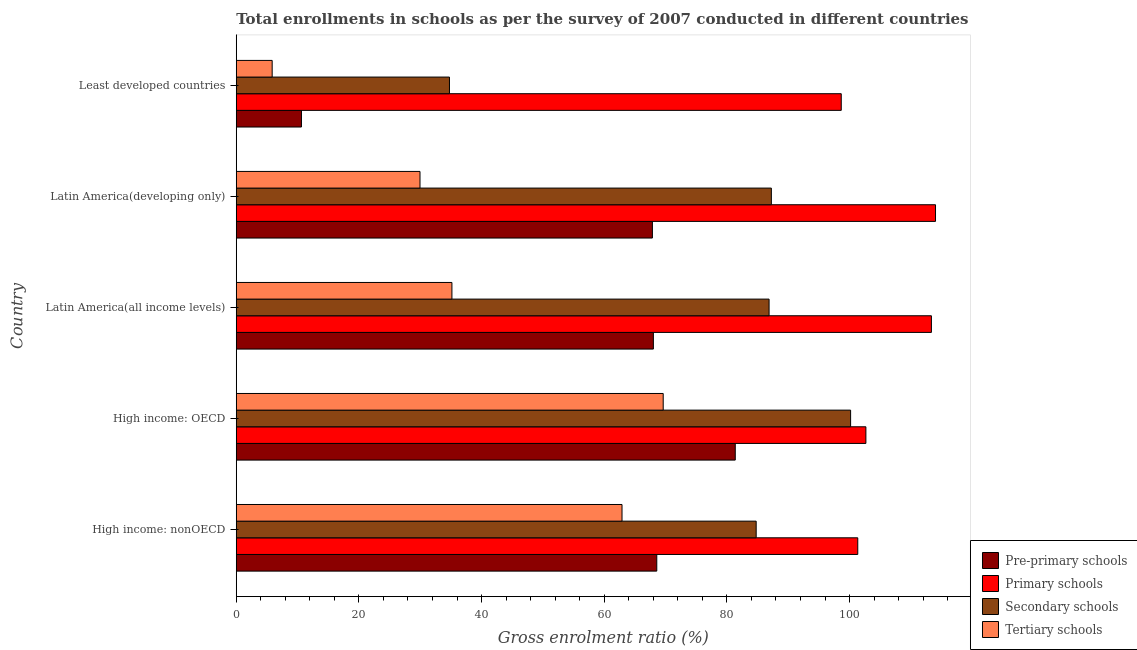Are the number of bars per tick equal to the number of legend labels?
Ensure brevity in your answer.  Yes. How many bars are there on the 4th tick from the top?
Your answer should be compact. 4. What is the label of the 2nd group of bars from the top?
Give a very brief answer. Latin America(developing only). What is the gross enrolment ratio in pre-primary schools in Least developed countries?
Provide a short and direct response. 10.63. Across all countries, what is the maximum gross enrolment ratio in tertiary schools?
Make the answer very short. 69.61. Across all countries, what is the minimum gross enrolment ratio in secondary schools?
Provide a short and direct response. 34.76. In which country was the gross enrolment ratio in pre-primary schools maximum?
Keep it short and to the point. High income: OECD. In which country was the gross enrolment ratio in pre-primary schools minimum?
Your response must be concise. Least developed countries. What is the total gross enrolment ratio in pre-primary schools in the graph?
Give a very brief answer. 296.41. What is the difference between the gross enrolment ratio in tertiary schools in High income: OECD and that in Latin America(developing only)?
Offer a terse response. 39.65. What is the difference between the gross enrolment ratio in secondary schools in High income: OECD and the gross enrolment ratio in pre-primary schools in High income: nonOECD?
Provide a short and direct response. 31.6. What is the average gross enrolment ratio in tertiary schools per country?
Ensure brevity in your answer.  40.7. What is the difference between the gross enrolment ratio in primary schools and gross enrolment ratio in pre-primary schools in Latin America(all income levels)?
Ensure brevity in your answer.  45.33. In how many countries, is the gross enrolment ratio in pre-primary schools greater than 44 %?
Provide a succinct answer. 4. What is the ratio of the gross enrolment ratio in pre-primary schools in Latin America(developing only) to that in Least developed countries?
Your answer should be compact. 6.38. Is the gross enrolment ratio in tertiary schools in High income: OECD less than that in High income: nonOECD?
Offer a very short reply. No. Is the difference between the gross enrolment ratio in secondary schools in High income: nonOECD and Latin America(all income levels) greater than the difference between the gross enrolment ratio in pre-primary schools in High income: nonOECD and Latin America(all income levels)?
Provide a succinct answer. No. What is the difference between the highest and the second highest gross enrolment ratio in tertiary schools?
Offer a very short reply. 6.72. What is the difference between the highest and the lowest gross enrolment ratio in primary schools?
Give a very brief answer. 15.37. In how many countries, is the gross enrolment ratio in primary schools greater than the average gross enrolment ratio in primary schools taken over all countries?
Provide a succinct answer. 2. Is the sum of the gross enrolment ratio in secondary schools in Latin America(developing only) and Least developed countries greater than the maximum gross enrolment ratio in tertiary schools across all countries?
Give a very brief answer. Yes. Is it the case that in every country, the sum of the gross enrolment ratio in tertiary schools and gross enrolment ratio in secondary schools is greater than the sum of gross enrolment ratio in primary schools and gross enrolment ratio in pre-primary schools?
Your answer should be very brief. No. What does the 2nd bar from the top in Least developed countries represents?
Give a very brief answer. Secondary schools. What does the 4th bar from the bottom in Latin America(developing only) represents?
Keep it short and to the point. Tertiary schools. Is it the case that in every country, the sum of the gross enrolment ratio in pre-primary schools and gross enrolment ratio in primary schools is greater than the gross enrolment ratio in secondary schools?
Your response must be concise. Yes. How many countries are there in the graph?
Make the answer very short. 5. Where does the legend appear in the graph?
Make the answer very short. Bottom right. What is the title of the graph?
Your answer should be compact. Total enrollments in schools as per the survey of 2007 conducted in different countries. Does "Taxes on revenue" appear as one of the legend labels in the graph?
Your answer should be compact. No. What is the label or title of the Y-axis?
Your answer should be compact. Country. What is the Gross enrolment ratio (%) in Pre-primary schools in High income: nonOECD?
Provide a succinct answer. 68.56. What is the Gross enrolment ratio (%) in Primary schools in High income: nonOECD?
Ensure brevity in your answer.  101.33. What is the Gross enrolment ratio (%) of Secondary schools in High income: nonOECD?
Provide a succinct answer. 84.77. What is the Gross enrolment ratio (%) in Tertiary schools in High income: nonOECD?
Keep it short and to the point. 62.9. What is the Gross enrolment ratio (%) in Pre-primary schools in High income: OECD?
Provide a succinct answer. 81.36. What is the Gross enrolment ratio (%) in Primary schools in High income: OECD?
Ensure brevity in your answer.  102.66. What is the Gross enrolment ratio (%) in Secondary schools in High income: OECD?
Offer a very short reply. 100.17. What is the Gross enrolment ratio (%) in Tertiary schools in High income: OECD?
Provide a succinct answer. 69.61. What is the Gross enrolment ratio (%) in Pre-primary schools in Latin America(all income levels)?
Keep it short and to the point. 68.01. What is the Gross enrolment ratio (%) in Primary schools in Latin America(all income levels)?
Make the answer very short. 113.34. What is the Gross enrolment ratio (%) of Secondary schools in Latin America(all income levels)?
Your answer should be compact. 86.87. What is the Gross enrolment ratio (%) of Tertiary schools in Latin America(all income levels)?
Make the answer very short. 35.16. What is the Gross enrolment ratio (%) of Pre-primary schools in Latin America(developing only)?
Make the answer very short. 67.85. What is the Gross enrolment ratio (%) in Primary schools in Latin America(developing only)?
Your response must be concise. 114.01. What is the Gross enrolment ratio (%) in Secondary schools in Latin America(developing only)?
Give a very brief answer. 87.24. What is the Gross enrolment ratio (%) of Tertiary schools in Latin America(developing only)?
Ensure brevity in your answer.  29.96. What is the Gross enrolment ratio (%) of Pre-primary schools in Least developed countries?
Your response must be concise. 10.63. What is the Gross enrolment ratio (%) in Primary schools in Least developed countries?
Give a very brief answer. 98.64. What is the Gross enrolment ratio (%) in Secondary schools in Least developed countries?
Provide a succinct answer. 34.76. What is the Gross enrolment ratio (%) of Tertiary schools in Least developed countries?
Offer a terse response. 5.86. Across all countries, what is the maximum Gross enrolment ratio (%) of Pre-primary schools?
Keep it short and to the point. 81.36. Across all countries, what is the maximum Gross enrolment ratio (%) in Primary schools?
Provide a succinct answer. 114.01. Across all countries, what is the maximum Gross enrolment ratio (%) in Secondary schools?
Provide a short and direct response. 100.17. Across all countries, what is the maximum Gross enrolment ratio (%) in Tertiary schools?
Your response must be concise. 69.61. Across all countries, what is the minimum Gross enrolment ratio (%) in Pre-primary schools?
Your answer should be compact. 10.63. Across all countries, what is the minimum Gross enrolment ratio (%) of Primary schools?
Make the answer very short. 98.64. Across all countries, what is the minimum Gross enrolment ratio (%) in Secondary schools?
Provide a succinct answer. 34.76. Across all countries, what is the minimum Gross enrolment ratio (%) of Tertiary schools?
Keep it short and to the point. 5.86. What is the total Gross enrolment ratio (%) of Pre-primary schools in the graph?
Your response must be concise. 296.41. What is the total Gross enrolment ratio (%) of Primary schools in the graph?
Your answer should be compact. 529.98. What is the total Gross enrolment ratio (%) in Secondary schools in the graph?
Ensure brevity in your answer.  393.82. What is the total Gross enrolment ratio (%) of Tertiary schools in the graph?
Make the answer very short. 203.49. What is the difference between the Gross enrolment ratio (%) in Pre-primary schools in High income: nonOECD and that in High income: OECD?
Your answer should be very brief. -12.8. What is the difference between the Gross enrolment ratio (%) in Primary schools in High income: nonOECD and that in High income: OECD?
Your answer should be compact. -1.33. What is the difference between the Gross enrolment ratio (%) of Secondary schools in High income: nonOECD and that in High income: OECD?
Make the answer very short. -15.4. What is the difference between the Gross enrolment ratio (%) in Tertiary schools in High income: nonOECD and that in High income: OECD?
Give a very brief answer. -6.72. What is the difference between the Gross enrolment ratio (%) of Pre-primary schools in High income: nonOECD and that in Latin America(all income levels)?
Offer a terse response. 0.56. What is the difference between the Gross enrolment ratio (%) of Primary schools in High income: nonOECD and that in Latin America(all income levels)?
Offer a very short reply. -12.01. What is the difference between the Gross enrolment ratio (%) in Secondary schools in High income: nonOECD and that in Latin America(all income levels)?
Offer a very short reply. -2.1. What is the difference between the Gross enrolment ratio (%) in Tertiary schools in High income: nonOECD and that in Latin America(all income levels)?
Your answer should be very brief. 27.73. What is the difference between the Gross enrolment ratio (%) in Pre-primary schools in High income: nonOECD and that in Latin America(developing only)?
Offer a very short reply. 0.71. What is the difference between the Gross enrolment ratio (%) in Primary schools in High income: nonOECD and that in Latin America(developing only)?
Give a very brief answer. -12.68. What is the difference between the Gross enrolment ratio (%) in Secondary schools in High income: nonOECD and that in Latin America(developing only)?
Ensure brevity in your answer.  -2.47. What is the difference between the Gross enrolment ratio (%) in Tertiary schools in High income: nonOECD and that in Latin America(developing only)?
Provide a short and direct response. 32.94. What is the difference between the Gross enrolment ratio (%) in Pre-primary schools in High income: nonOECD and that in Least developed countries?
Offer a very short reply. 57.93. What is the difference between the Gross enrolment ratio (%) of Primary schools in High income: nonOECD and that in Least developed countries?
Your answer should be compact. 2.69. What is the difference between the Gross enrolment ratio (%) of Secondary schools in High income: nonOECD and that in Least developed countries?
Your response must be concise. 50.01. What is the difference between the Gross enrolment ratio (%) in Tertiary schools in High income: nonOECD and that in Least developed countries?
Your response must be concise. 57.04. What is the difference between the Gross enrolment ratio (%) in Pre-primary schools in High income: OECD and that in Latin America(all income levels)?
Your response must be concise. 13.35. What is the difference between the Gross enrolment ratio (%) in Primary schools in High income: OECD and that in Latin America(all income levels)?
Give a very brief answer. -10.68. What is the difference between the Gross enrolment ratio (%) of Secondary schools in High income: OECD and that in Latin America(all income levels)?
Your answer should be very brief. 13.29. What is the difference between the Gross enrolment ratio (%) of Tertiary schools in High income: OECD and that in Latin America(all income levels)?
Your answer should be compact. 34.45. What is the difference between the Gross enrolment ratio (%) in Pre-primary schools in High income: OECD and that in Latin America(developing only)?
Provide a short and direct response. 13.51. What is the difference between the Gross enrolment ratio (%) of Primary schools in High income: OECD and that in Latin America(developing only)?
Provide a short and direct response. -11.35. What is the difference between the Gross enrolment ratio (%) in Secondary schools in High income: OECD and that in Latin America(developing only)?
Offer a very short reply. 12.92. What is the difference between the Gross enrolment ratio (%) in Tertiary schools in High income: OECD and that in Latin America(developing only)?
Offer a very short reply. 39.65. What is the difference between the Gross enrolment ratio (%) in Pre-primary schools in High income: OECD and that in Least developed countries?
Provide a short and direct response. 70.73. What is the difference between the Gross enrolment ratio (%) in Primary schools in High income: OECD and that in Least developed countries?
Your answer should be very brief. 4.02. What is the difference between the Gross enrolment ratio (%) of Secondary schools in High income: OECD and that in Least developed countries?
Provide a short and direct response. 65.4. What is the difference between the Gross enrolment ratio (%) in Tertiary schools in High income: OECD and that in Least developed countries?
Your answer should be compact. 63.76. What is the difference between the Gross enrolment ratio (%) in Pre-primary schools in Latin America(all income levels) and that in Latin America(developing only)?
Offer a terse response. 0.16. What is the difference between the Gross enrolment ratio (%) of Primary schools in Latin America(all income levels) and that in Latin America(developing only)?
Provide a succinct answer. -0.67. What is the difference between the Gross enrolment ratio (%) in Secondary schools in Latin America(all income levels) and that in Latin America(developing only)?
Provide a succinct answer. -0.37. What is the difference between the Gross enrolment ratio (%) in Tertiary schools in Latin America(all income levels) and that in Latin America(developing only)?
Your answer should be very brief. 5.2. What is the difference between the Gross enrolment ratio (%) of Pre-primary schools in Latin America(all income levels) and that in Least developed countries?
Ensure brevity in your answer.  57.38. What is the difference between the Gross enrolment ratio (%) of Primary schools in Latin America(all income levels) and that in Least developed countries?
Your response must be concise. 14.7. What is the difference between the Gross enrolment ratio (%) of Secondary schools in Latin America(all income levels) and that in Least developed countries?
Make the answer very short. 52.11. What is the difference between the Gross enrolment ratio (%) in Tertiary schools in Latin America(all income levels) and that in Least developed countries?
Your answer should be very brief. 29.31. What is the difference between the Gross enrolment ratio (%) of Pre-primary schools in Latin America(developing only) and that in Least developed countries?
Give a very brief answer. 57.22. What is the difference between the Gross enrolment ratio (%) in Primary schools in Latin America(developing only) and that in Least developed countries?
Your response must be concise. 15.37. What is the difference between the Gross enrolment ratio (%) in Secondary schools in Latin America(developing only) and that in Least developed countries?
Give a very brief answer. 52.48. What is the difference between the Gross enrolment ratio (%) of Tertiary schools in Latin America(developing only) and that in Least developed countries?
Provide a short and direct response. 24.1. What is the difference between the Gross enrolment ratio (%) of Pre-primary schools in High income: nonOECD and the Gross enrolment ratio (%) of Primary schools in High income: OECD?
Your answer should be compact. -34.09. What is the difference between the Gross enrolment ratio (%) of Pre-primary schools in High income: nonOECD and the Gross enrolment ratio (%) of Secondary schools in High income: OECD?
Give a very brief answer. -31.6. What is the difference between the Gross enrolment ratio (%) in Pre-primary schools in High income: nonOECD and the Gross enrolment ratio (%) in Tertiary schools in High income: OECD?
Keep it short and to the point. -1.05. What is the difference between the Gross enrolment ratio (%) in Primary schools in High income: nonOECD and the Gross enrolment ratio (%) in Secondary schools in High income: OECD?
Keep it short and to the point. 1.17. What is the difference between the Gross enrolment ratio (%) in Primary schools in High income: nonOECD and the Gross enrolment ratio (%) in Tertiary schools in High income: OECD?
Make the answer very short. 31.72. What is the difference between the Gross enrolment ratio (%) of Secondary schools in High income: nonOECD and the Gross enrolment ratio (%) of Tertiary schools in High income: OECD?
Offer a very short reply. 15.16. What is the difference between the Gross enrolment ratio (%) in Pre-primary schools in High income: nonOECD and the Gross enrolment ratio (%) in Primary schools in Latin America(all income levels)?
Offer a very short reply. -44.78. What is the difference between the Gross enrolment ratio (%) in Pre-primary schools in High income: nonOECD and the Gross enrolment ratio (%) in Secondary schools in Latin America(all income levels)?
Provide a succinct answer. -18.31. What is the difference between the Gross enrolment ratio (%) of Pre-primary schools in High income: nonOECD and the Gross enrolment ratio (%) of Tertiary schools in Latin America(all income levels)?
Your response must be concise. 33.4. What is the difference between the Gross enrolment ratio (%) in Primary schools in High income: nonOECD and the Gross enrolment ratio (%) in Secondary schools in Latin America(all income levels)?
Make the answer very short. 14.46. What is the difference between the Gross enrolment ratio (%) of Primary schools in High income: nonOECD and the Gross enrolment ratio (%) of Tertiary schools in Latin America(all income levels)?
Keep it short and to the point. 66.17. What is the difference between the Gross enrolment ratio (%) in Secondary schools in High income: nonOECD and the Gross enrolment ratio (%) in Tertiary schools in Latin America(all income levels)?
Ensure brevity in your answer.  49.61. What is the difference between the Gross enrolment ratio (%) of Pre-primary schools in High income: nonOECD and the Gross enrolment ratio (%) of Primary schools in Latin America(developing only)?
Your answer should be very brief. -45.45. What is the difference between the Gross enrolment ratio (%) in Pre-primary schools in High income: nonOECD and the Gross enrolment ratio (%) in Secondary schools in Latin America(developing only)?
Give a very brief answer. -18.68. What is the difference between the Gross enrolment ratio (%) of Pre-primary schools in High income: nonOECD and the Gross enrolment ratio (%) of Tertiary schools in Latin America(developing only)?
Your answer should be compact. 38.6. What is the difference between the Gross enrolment ratio (%) in Primary schools in High income: nonOECD and the Gross enrolment ratio (%) in Secondary schools in Latin America(developing only)?
Keep it short and to the point. 14.09. What is the difference between the Gross enrolment ratio (%) in Primary schools in High income: nonOECD and the Gross enrolment ratio (%) in Tertiary schools in Latin America(developing only)?
Give a very brief answer. 71.37. What is the difference between the Gross enrolment ratio (%) in Secondary schools in High income: nonOECD and the Gross enrolment ratio (%) in Tertiary schools in Latin America(developing only)?
Your answer should be compact. 54.81. What is the difference between the Gross enrolment ratio (%) in Pre-primary schools in High income: nonOECD and the Gross enrolment ratio (%) in Primary schools in Least developed countries?
Give a very brief answer. -30.08. What is the difference between the Gross enrolment ratio (%) in Pre-primary schools in High income: nonOECD and the Gross enrolment ratio (%) in Secondary schools in Least developed countries?
Provide a short and direct response. 33.8. What is the difference between the Gross enrolment ratio (%) in Pre-primary schools in High income: nonOECD and the Gross enrolment ratio (%) in Tertiary schools in Least developed countries?
Ensure brevity in your answer.  62.71. What is the difference between the Gross enrolment ratio (%) in Primary schools in High income: nonOECD and the Gross enrolment ratio (%) in Secondary schools in Least developed countries?
Ensure brevity in your answer.  66.57. What is the difference between the Gross enrolment ratio (%) in Primary schools in High income: nonOECD and the Gross enrolment ratio (%) in Tertiary schools in Least developed countries?
Offer a very short reply. 95.48. What is the difference between the Gross enrolment ratio (%) in Secondary schools in High income: nonOECD and the Gross enrolment ratio (%) in Tertiary schools in Least developed countries?
Make the answer very short. 78.91. What is the difference between the Gross enrolment ratio (%) of Pre-primary schools in High income: OECD and the Gross enrolment ratio (%) of Primary schools in Latin America(all income levels)?
Keep it short and to the point. -31.98. What is the difference between the Gross enrolment ratio (%) in Pre-primary schools in High income: OECD and the Gross enrolment ratio (%) in Secondary schools in Latin America(all income levels)?
Offer a terse response. -5.51. What is the difference between the Gross enrolment ratio (%) in Pre-primary schools in High income: OECD and the Gross enrolment ratio (%) in Tertiary schools in Latin America(all income levels)?
Offer a very short reply. 46.2. What is the difference between the Gross enrolment ratio (%) in Primary schools in High income: OECD and the Gross enrolment ratio (%) in Secondary schools in Latin America(all income levels)?
Ensure brevity in your answer.  15.78. What is the difference between the Gross enrolment ratio (%) in Primary schools in High income: OECD and the Gross enrolment ratio (%) in Tertiary schools in Latin America(all income levels)?
Your response must be concise. 67.5. What is the difference between the Gross enrolment ratio (%) of Secondary schools in High income: OECD and the Gross enrolment ratio (%) of Tertiary schools in Latin America(all income levels)?
Ensure brevity in your answer.  65. What is the difference between the Gross enrolment ratio (%) of Pre-primary schools in High income: OECD and the Gross enrolment ratio (%) of Primary schools in Latin America(developing only)?
Make the answer very short. -32.65. What is the difference between the Gross enrolment ratio (%) of Pre-primary schools in High income: OECD and the Gross enrolment ratio (%) of Secondary schools in Latin America(developing only)?
Ensure brevity in your answer.  -5.88. What is the difference between the Gross enrolment ratio (%) of Pre-primary schools in High income: OECD and the Gross enrolment ratio (%) of Tertiary schools in Latin America(developing only)?
Your answer should be very brief. 51.4. What is the difference between the Gross enrolment ratio (%) in Primary schools in High income: OECD and the Gross enrolment ratio (%) in Secondary schools in Latin America(developing only)?
Provide a short and direct response. 15.41. What is the difference between the Gross enrolment ratio (%) of Primary schools in High income: OECD and the Gross enrolment ratio (%) of Tertiary schools in Latin America(developing only)?
Your answer should be compact. 72.7. What is the difference between the Gross enrolment ratio (%) of Secondary schools in High income: OECD and the Gross enrolment ratio (%) of Tertiary schools in Latin America(developing only)?
Give a very brief answer. 70.21. What is the difference between the Gross enrolment ratio (%) of Pre-primary schools in High income: OECD and the Gross enrolment ratio (%) of Primary schools in Least developed countries?
Offer a very short reply. -17.28. What is the difference between the Gross enrolment ratio (%) of Pre-primary schools in High income: OECD and the Gross enrolment ratio (%) of Secondary schools in Least developed countries?
Your answer should be very brief. 46.6. What is the difference between the Gross enrolment ratio (%) in Pre-primary schools in High income: OECD and the Gross enrolment ratio (%) in Tertiary schools in Least developed countries?
Offer a terse response. 75.5. What is the difference between the Gross enrolment ratio (%) of Primary schools in High income: OECD and the Gross enrolment ratio (%) of Secondary schools in Least developed countries?
Ensure brevity in your answer.  67.89. What is the difference between the Gross enrolment ratio (%) of Primary schools in High income: OECD and the Gross enrolment ratio (%) of Tertiary schools in Least developed countries?
Provide a succinct answer. 96.8. What is the difference between the Gross enrolment ratio (%) of Secondary schools in High income: OECD and the Gross enrolment ratio (%) of Tertiary schools in Least developed countries?
Ensure brevity in your answer.  94.31. What is the difference between the Gross enrolment ratio (%) of Pre-primary schools in Latin America(all income levels) and the Gross enrolment ratio (%) of Primary schools in Latin America(developing only)?
Provide a succinct answer. -46. What is the difference between the Gross enrolment ratio (%) of Pre-primary schools in Latin America(all income levels) and the Gross enrolment ratio (%) of Secondary schools in Latin America(developing only)?
Ensure brevity in your answer.  -19.24. What is the difference between the Gross enrolment ratio (%) in Pre-primary schools in Latin America(all income levels) and the Gross enrolment ratio (%) in Tertiary schools in Latin America(developing only)?
Offer a terse response. 38.05. What is the difference between the Gross enrolment ratio (%) in Primary schools in Latin America(all income levels) and the Gross enrolment ratio (%) in Secondary schools in Latin America(developing only)?
Offer a very short reply. 26.1. What is the difference between the Gross enrolment ratio (%) in Primary schools in Latin America(all income levels) and the Gross enrolment ratio (%) in Tertiary schools in Latin America(developing only)?
Your answer should be compact. 83.38. What is the difference between the Gross enrolment ratio (%) in Secondary schools in Latin America(all income levels) and the Gross enrolment ratio (%) in Tertiary schools in Latin America(developing only)?
Provide a short and direct response. 56.91. What is the difference between the Gross enrolment ratio (%) of Pre-primary schools in Latin America(all income levels) and the Gross enrolment ratio (%) of Primary schools in Least developed countries?
Your answer should be compact. -30.63. What is the difference between the Gross enrolment ratio (%) in Pre-primary schools in Latin America(all income levels) and the Gross enrolment ratio (%) in Secondary schools in Least developed countries?
Offer a very short reply. 33.24. What is the difference between the Gross enrolment ratio (%) in Pre-primary schools in Latin America(all income levels) and the Gross enrolment ratio (%) in Tertiary schools in Least developed countries?
Ensure brevity in your answer.  62.15. What is the difference between the Gross enrolment ratio (%) of Primary schools in Latin America(all income levels) and the Gross enrolment ratio (%) of Secondary schools in Least developed countries?
Offer a very short reply. 78.58. What is the difference between the Gross enrolment ratio (%) of Primary schools in Latin America(all income levels) and the Gross enrolment ratio (%) of Tertiary schools in Least developed countries?
Provide a succinct answer. 107.48. What is the difference between the Gross enrolment ratio (%) of Secondary schools in Latin America(all income levels) and the Gross enrolment ratio (%) of Tertiary schools in Least developed countries?
Provide a succinct answer. 81.02. What is the difference between the Gross enrolment ratio (%) in Pre-primary schools in Latin America(developing only) and the Gross enrolment ratio (%) in Primary schools in Least developed countries?
Keep it short and to the point. -30.79. What is the difference between the Gross enrolment ratio (%) of Pre-primary schools in Latin America(developing only) and the Gross enrolment ratio (%) of Secondary schools in Least developed countries?
Offer a terse response. 33.09. What is the difference between the Gross enrolment ratio (%) of Pre-primary schools in Latin America(developing only) and the Gross enrolment ratio (%) of Tertiary schools in Least developed countries?
Your answer should be compact. 61.99. What is the difference between the Gross enrolment ratio (%) of Primary schools in Latin America(developing only) and the Gross enrolment ratio (%) of Secondary schools in Least developed countries?
Keep it short and to the point. 79.25. What is the difference between the Gross enrolment ratio (%) in Primary schools in Latin America(developing only) and the Gross enrolment ratio (%) in Tertiary schools in Least developed countries?
Provide a short and direct response. 108.15. What is the difference between the Gross enrolment ratio (%) in Secondary schools in Latin America(developing only) and the Gross enrolment ratio (%) in Tertiary schools in Least developed countries?
Ensure brevity in your answer.  81.39. What is the average Gross enrolment ratio (%) of Pre-primary schools per country?
Make the answer very short. 59.28. What is the average Gross enrolment ratio (%) in Primary schools per country?
Offer a very short reply. 106. What is the average Gross enrolment ratio (%) in Secondary schools per country?
Your response must be concise. 78.76. What is the average Gross enrolment ratio (%) of Tertiary schools per country?
Ensure brevity in your answer.  40.7. What is the difference between the Gross enrolment ratio (%) in Pre-primary schools and Gross enrolment ratio (%) in Primary schools in High income: nonOECD?
Provide a succinct answer. -32.77. What is the difference between the Gross enrolment ratio (%) of Pre-primary schools and Gross enrolment ratio (%) of Secondary schools in High income: nonOECD?
Your answer should be compact. -16.21. What is the difference between the Gross enrolment ratio (%) of Pre-primary schools and Gross enrolment ratio (%) of Tertiary schools in High income: nonOECD?
Provide a succinct answer. 5.67. What is the difference between the Gross enrolment ratio (%) of Primary schools and Gross enrolment ratio (%) of Secondary schools in High income: nonOECD?
Your answer should be very brief. 16.56. What is the difference between the Gross enrolment ratio (%) of Primary schools and Gross enrolment ratio (%) of Tertiary schools in High income: nonOECD?
Keep it short and to the point. 38.44. What is the difference between the Gross enrolment ratio (%) of Secondary schools and Gross enrolment ratio (%) of Tertiary schools in High income: nonOECD?
Make the answer very short. 21.88. What is the difference between the Gross enrolment ratio (%) of Pre-primary schools and Gross enrolment ratio (%) of Primary schools in High income: OECD?
Keep it short and to the point. -21.3. What is the difference between the Gross enrolment ratio (%) of Pre-primary schools and Gross enrolment ratio (%) of Secondary schools in High income: OECD?
Your response must be concise. -18.8. What is the difference between the Gross enrolment ratio (%) of Pre-primary schools and Gross enrolment ratio (%) of Tertiary schools in High income: OECD?
Ensure brevity in your answer.  11.75. What is the difference between the Gross enrolment ratio (%) of Primary schools and Gross enrolment ratio (%) of Secondary schools in High income: OECD?
Keep it short and to the point. 2.49. What is the difference between the Gross enrolment ratio (%) in Primary schools and Gross enrolment ratio (%) in Tertiary schools in High income: OECD?
Your response must be concise. 33.05. What is the difference between the Gross enrolment ratio (%) in Secondary schools and Gross enrolment ratio (%) in Tertiary schools in High income: OECD?
Give a very brief answer. 30.55. What is the difference between the Gross enrolment ratio (%) of Pre-primary schools and Gross enrolment ratio (%) of Primary schools in Latin America(all income levels)?
Provide a succinct answer. -45.33. What is the difference between the Gross enrolment ratio (%) in Pre-primary schools and Gross enrolment ratio (%) in Secondary schools in Latin America(all income levels)?
Ensure brevity in your answer.  -18.87. What is the difference between the Gross enrolment ratio (%) in Pre-primary schools and Gross enrolment ratio (%) in Tertiary schools in Latin America(all income levels)?
Make the answer very short. 32.85. What is the difference between the Gross enrolment ratio (%) in Primary schools and Gross enrolment ratio (%) in Secondary schools in Latin America(all income levels)?
Keep it short and to the point. 26.47. What is the difference between the Gross enrolment ratio (%) of Primary schools and Gross enrolment ratio (%) of Tertiary schools in Latin America(all income levels)?
Your response must be concise. 78.18. What is the difference between the Gross enrolment ratio (%) in Secondary schools and Gross enrolment ratio (%) in Tertiary schools in Latin America(all income levels)?
Keep it short and to the point. 51.71. What is the difference between the Gross enrolment ratio (%) in Pre-primary schools and Gross enrolment ratio (%) in Primary schools in Latin America(developing only)?
Keep it short and to the point. -46.16. What is the difference between the Gross enrolment ratio (%) in Pre-primary schools and Gross enrolment ratio (%) in Secondary schools in Latin America(developing only)?
Provide a short and direct response. -19.39. What is the difference between the Gross enrolment ratio (%) of Pre-primary schools and Gross enrolment ratio (%) of Tertiary schools in Latin America(developing only)?
Ensure brevity in your answer.  37.89. What is the difference between the Gross enrolment ratio (%) of Primary schools and Gross enrolment ratio (%) of Secondary schools in Latin America(developing only)?
Keep it short and to the point. 26.76. What is the difference between the Gross enrolment ratio (%) in Primary schools and Gross enrolment ratio (%) in Tertiary schools in Latin America(developing only)?
Offer a very short reply. 84.05. What is the difference between the Gross enrolment ratio (%) in Secondary schools and Gross enrolment ratio (%) in Tertiary schools in Latin America(developing only)?
Offer a terse response. 57.29. What is the difference between the Gross enrolment ratio (%) of Pre-primary schools and Gross enrolment ratio (%) of Primary schools in Least developed countries?
Offer a terse response. -88.01. What is the difference between the Gross enrolment ratio (%) of Pre-primary schools and Gross enrolment ratio (%) of Secondary schools in Least developed countries?
Offer a terse response. -24.13. What is the difference between the Gross enrolment ratio (%) of Pre-primary schools and Gross enrolment ratio (%) of Tertiary schools in Least developed countries?
Your answer should be compact. 4.77. What is the difference between the Gross enrolment ratio (%) of Primary schools and Gross enrolment ratio (%) of Secondary schools in Least developed countries?
Your answer should be compact. 63.88. What is the difference between the Gross enrolment ratio (%) in Primary schools and Gross enrolment ratio (%) in Tertiary schools in Least developed countries?
Make the answer very short. 92.78. What is the difference between the Gross enrolment ratio (%) in Secondary schools and Gross enrolment ratio (%) in Tertiary schools in Least developed countries?
Offer a very short reply. 28.91. What is the ratio of the Gross enrolment ratio (%) in Pre-primary schools in High income: nonOECD to that in High income: OECD?
Give a very brief answer. 0.84. What is the ratio of the Gross enrolment ratio (%) in Primary schools in High income: nonOECD to that in High income: OECD?
Keep it short and to the point. 0.99. What is the ratio of the Gross enrolment ratio (%) in Secondary schools in High income: nonOECD to that in High income: OECD?
Keep it short and to the point. 0.85. What is the ratio of the Gross enrolment ratio (%) of Tertiary schools in High income: nonOECD to that in High income: OECD?
Your response must be concise. 0.9. What is the ratio of the Gross enrolment ratio (%) in Pre-primary schools in High income: nonOECD to that in Latin America(all income levels)?
Provide a short and direct response. 1.01. What is the ratio of the Gross enrolment ratio (%) in Primary schools in High income: nonOECD to that in Latin America(all income levels)?
Make the answer very short. 0.89. What is the ratio of the Gross enrolment ratio (%) in Secondary schools in High income: nonOECD to that in Latin America(all income levels)?
Your response must be concise. 0.98. What is the ratio of the Gross enrolment ratio (%) in Tertiary schools in High income: nonOECD to that in Latin America(all income levels)?
Ensure brevity in your answer.  1.79. What is the ratio of the Gross enrolment ratio (%) in Pre-primary schools in High income: nonOECD to that in Latin America(developing only)?
Ensure brevity in your answer.  1.01. What is the ratio of the Gross enrolment ratio (%) in Primary schools in High income: nonOECD to that in Latin America(developing only)?
Your answer should be very brief. 0.89. What is the ratio of the Gross enrolment ratio (%) of Secondary schools in High income: nonOECD to that in Latin America(developing only)?
Provide a succinct answer. 0.97. What is the ratio of the Gross enrolment ratio (%) in Tertiary schools in High income: nonOECD to that in Latin America(developing only)?
Give a very brief answer. 2.1. What is the ratio of the Gross enrolment ratio (%) of Pre-primary schools in High income: nonOECD to that in Least developed countries?
Offer a terse response. 6.45. What is the ratio of the Gross enrolment ratio (%) in Primary schools in High income: nonOECD to that in Least developed countries?
Your answer should be very brief. 1.03. What is the ratio of the Gross enrolment ratio (%) of Secondary schools in High income: nonOECD to that in Least developed countries?
Give a very brief answer. 2.44. What is the ratio of the Gross enrolment ratio (%) in Tertiary schools in High income: nonOECD to that in Least developed countries?
Offer a terse response. 10.74. What is the ratio of the Gross enrolment ratio (%) in Pre-primary schools in High income: OECD to that in Latin America(all income levels)?
Keep it short and to the point. 1.2. What is the ratio of the Gross enrolment ratio (%) of Primary schools in High income: OECD to that in Latin America(all income levels)?
Make the answer very short. 0.91. What is the ratio of the Gross enrolment ratio (%) of Secondary schools in High income: OECD to that in Latin America(all income levels)?
Provide a succinct answer. 1.15. What is the ratio of the Gross enrolment ratio (%) of Tertiary schools in High income: OECD to that in Latin America(all income levels)?
Your answer should be very brief. 1.98. What is the ratio of the Gross enrolment ratio (%) of Pre-primary schools in High income: OECD to that in Latin America(developing only)?
Your answer should be compact. 1.2. What is the ratio of the Gross enrolment ratio (%) of Primary schools in High income: OECD to that in Latin America(developing only)?
Make the answer very short. 0.9. What is the ratio of the Gross enrolment ratio (%) of Secondary schools in High income: OECD to that in Latin America(developing only)?
Provide a short and direct response. 1.15. What is the ratio of the Gross enrolment ratio (%) of Tertiary schools in High income: OECD to that in Latin America(developing only)?
Provide a succinct answer. 2.32. What is the ratio of the Gross enrolment ratio (%) in Pre-primary schools in High income: OECD to that in Least developed countries?
Your response must be concise. 7.65. What is the ratio of the Gross enrolment ratio (%) of Primary schools in High income: OECD to that in Least developed countries?
Your answer should be very brief. 1.04. What is the ratio of the Gross enrolment ratio (%) of Secondary schools in High income: OECD to that in Least developed countries?
Your response must be concise. 2.88. What is the ratio of the Gross enrolment ratio (%) in Tertiary schools in High income: OECD to that in Least developed countries?
Provide a succinct answer. 11.89. What is the ratio of the Gross enrolment ratio (%) in Pre-primary schools in Latin America(all income levels) to that in Latin America(developing only)?
Your answer should be very brief. 1. What is the ratio of the Gross enrolment ratio (%) in Tertiary schools in Latin America(all income levels) to that in Latin America(developing only)?
Provide a short and direct response. 1.17. What is the ratio of the Gross enrolment ratio (%) in Pre-primary schools in Latin America(all income levels) to that in Least developed countries?
Provide a short and direct response. 6.4. What is the ratio of the Gross enrolment ratio (%) of Primary schools in Latin America(all income levels) to that in Least developed countries?
Provide a short and direct response. 1.15. What is the ratio of the Gross enrolment ratio (%) in Secondary schools in Latin America(all income levels) to that in Least developed countries?
Provide a succinct answer. 2.5. What is the ratio of the Gross enrolment ratio (%) in Tertiary schools in Latin America(all income levels) to that in Least developed countries?
Make the answer very short. 6. What is the ratio of the Gross enrolment ratio (%) of Pre-primary schools in Latin America(developing only) to that in Least developed countries?
Your answer should be very brief. 6.38. What is the ratio of the Gross enrolment ratio (%) of Primary schools in Latin America(developing only) to that in Least developed countries?
Keep it short and to the point. 1.16. What is the ratio of the Gross enrolment ratio (%) in Secondary schools in Latin America(developing only) to that in Least developed countries?
Your answer should be compact. 2.51. What is the ratio of the Gross enrolment ratio (%) of Tertiary schools in Latin America(developing only) to that in Least developed countries?
Provide a succinct answer. 5.12. What is the difference between the highest and the second highest Gross enrolment ratio (%) in Pre-primary schools?
Offer a terse response. 12.8. What is the difference between the highest and the second highest Gross enrolment ratio (%) in Primary schools?
Provide a short and direct response. 0.67. What is the difference between the highest and the second highest Gross enrolment ratio (%) of Secondary schools?
Keep it short and to the point. 12.92. What is the difference between the highest and the second highest Gross enrolment ratio (%) in Tertiary schools?
Give a very brief answer. 6.72. What is the difference between the highest and the lowest Gross enrolment ratio (%) in Pre-primary schools?
Provide a succinct answer. 70.73. What is the difference between the highest and the lowest Gross enrolment ratio (%) in Primary schools?
Provide a short and direct response. 15.37. What is the difference between the highest and the lowest Gross enrolment ratio (%) of Secondary schools?
Give a very brief answer. 65.4. What is the difference between the highest and the lowest Gross enrolment ratio (%) in Tertiary schools?
Offer a terse response. 63.76. 